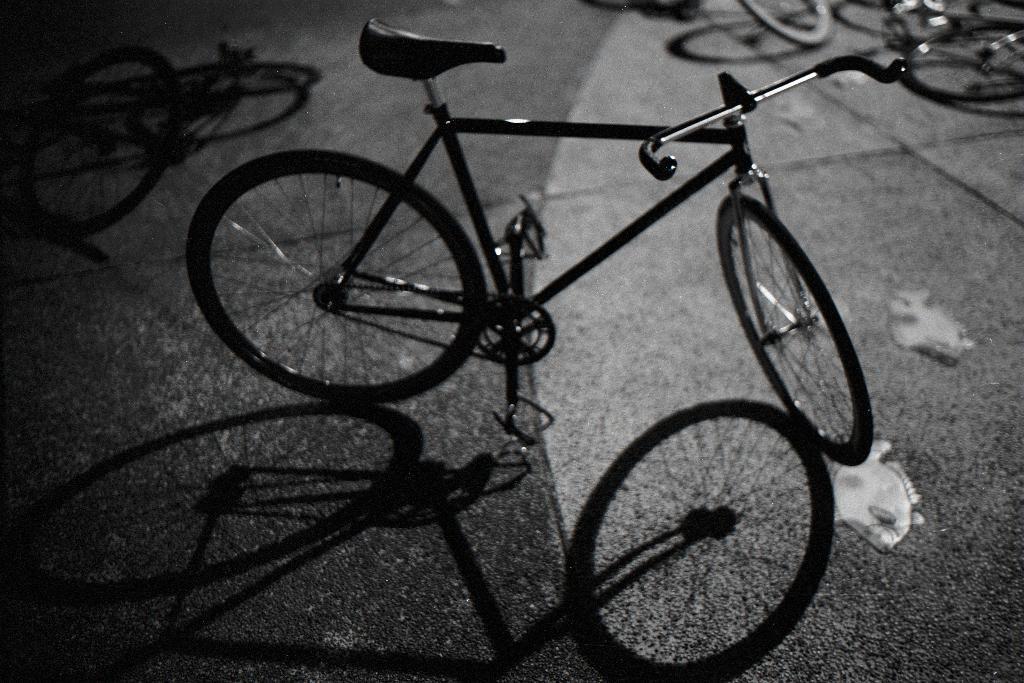Could you give a brief overview of what you see in this image? In this picture we can see bicycles, at the bottom we can see a shadow of a bicycle, we can also see tiles at the bottom. 